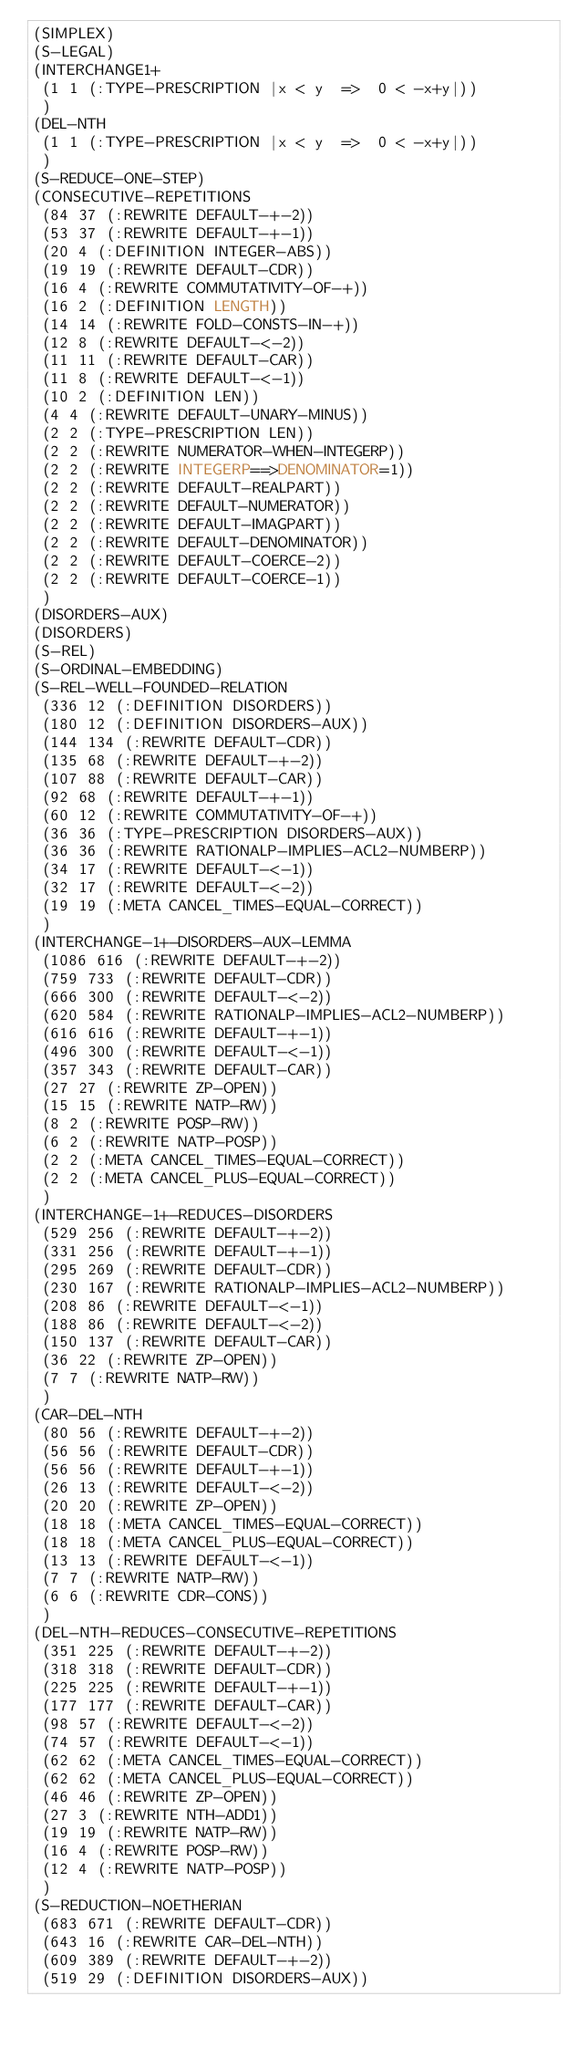<code> <loc_0><loc_0><loc_500><loc_500><_Lisp_>(SIMPLEX)
(S-LEGAL)
(INTERCHANGE1+
 (1 1 (:TYPE-PRESCRIPTION |x < y  =>  0 < -x+y|))
 )
(DEL-NTH
 (1 1 (:TYPE-PRESCRIPTION |x < y  =>  0 < -x+y|))
 )
(S-REDUCE-ONE-STEP)
(CONSECUTIVE-REPETITIONS
 (84 37 (:REWRITE DEFAULT-+-2))
 (53 37 (:REWRITE DEFAULT-+-1))
 (20 4 (:DEFINITION INTEGER-ABS))
 (19 19 (:REWRITE DEFAULT-CDR))
 (16 4 (:REWRITE COMMUTATIVITY-OF-+))
 (16 2 (:DEFINITION LENGTH))
 (14 14 (:REWRITE FOLD-CONSTS-IN-+))
 (12 8 (:REWRITE DEFAULT-<-2))
 (11 11 (:REWRITE DEFAULT-CAR))
 (11 8 (:REWRITE DEFAULT-<-1))
 (10 2 (:DEFINITION LEN))
 (4 4 (:REWRITE DEFAULT-UNARY-MINUS))
 (2 2 (:TYPE-PRESCRIPTION LEN))
 (2 2 (:REWRITE NUMERATOR-WHEN-INTEGERP))
 (2 2 (:REWRITE INTEGERP==>DENOMINATOR=1))
 (2 2 (:REWRITE DEFAULT-REALPART))
 (2 2 (:REWRITE DEFAULT-NUMERATOR))
 (2 2 (:REWRITE DEFAULT-IMAGPART))
 (2 2 (:REWRITE DEFAULT-DENOMINATOR))
 (2 2 (:REWRITE DEFAULT-COERCE-2))
 (2 2 (:REWRITE DEFAULT-COERCE-1))
 )
(DISORDERS-AUX)
(DISORDERS)
(S-REL)
(S-ORDINAL-EMBEDDING)
(S-REL-WELL-FOUNDED-RELATION
 (336 12 (:DEFINITION DISORDERS))
 (180 12 (:DEFINITION DISORDERS-AUX))
 (144 134 (:REWRITE DEFAULT-CDR))
 (135 68 (:REWRITE DEFAULT-+-2))
 (107 88 (:REWRITE DEFAULT-CAR))
 (92 68 (:REWRITE DEFAULT-+-1))
 (60 12 (:REWRITE COMMUTATIVITY-OF-+))
 (36 36 (:TYPE-PRESCRIPTION DISORDERS-AUX))
 (36 36 (:REWRITE RATIONALP-IMPLIES-ACL2-NUMBERP))
 (34 17 (:REWRITE DEFAULT-<-1))
 (32 17 (:REWRITE DEFAULT-<-2))
 (19 19 (:META CANCEL_TIMES-EQUAL-CORRECT))
 )
(INTERCHANGE-1+-DISORDERS-AUX-LEMMA
 (1086 616 (:REWRITE DEFAULT-+-2))
 (759 733 (:REWRITE DEFAULT-CDR))
 (666 300 (:REWRITE DEFAULT-<-2))
 (620 584 (:REWRITE RATIONALP-IMPLIES-ACL2-NUMBERP))
 (616 616 (:REWRITE DEFAULT-+-1))
 (496 300 (:REWRITE DEFAULT-<-1))
 (357 343 (:REWRITE DEFAULT-CAR))
 (27 27 (:REWRITE ZP-OPEN))
 (15 15 (:REWRITE NATP-RW))
 (8 2 (:REWRITE POSP-RW))
 (6 2 (:REWRITE NATP-POSP))
 (2 2 (:META CANCEL_TIMES-EQUAL-CORRECT))
 (2 2 (:META CANCEL_PLUS-EQUAL-CORRECT))
 )
(INTERCHANGE-1+-REDUCES-DISORDERS
 (529 256 (:REWRITE DEFAULT-+-2))
 (331 256 (:REWRITE DEFAULT-+-1))
 (295 269 (:REWRITE DEFAULT-CDR))
 (230 167 (:REWRITE RATIONALP-IMPLIES-ACL2-NUMBERP))
 (208 86 (:REWRITE DEFAULT-<-1))
 (188 86 (:REWRITE DEFAULT-<-2))
 (150 137 (:REWRITE DEFAULT-CAR))
 (36 22 (:REWRITE ZP-OPEN))
 (7 7 (:REWRITE NATP-RW))
 )
(CAR-DEL-NTH
 (80 56 (:REWRITE DEFAULT-+-2))
 (56 56 (:REWRITE DEFAULT-CDR))
 (56 56 (:REWRITE DEFAULT-+-1))
 (26 13 (:REWRITE DEFAULT-<-2))
 (20 20 (:REWRITE ZP-OPEN))
 (18 18 (:META CANCEL_TIMES-EQUAL-CORRECT))
 (18 18 (:META CANCEL_PLUS-EQUAL-CORRECT))
 (13 13 (:REWRITE DEFAULT-<-1))
 (7 7 (:REWRITE NATP-RW))
 (6 6 (:REWRITE CDR-CONS))
 )
(DEL-NTH-REDUCES-CONSECUTIVE-REPETITIONS
 (351 225 (:REWRITE DEFAULT-+-2))
 (318 318 (:REWRITE DEFAULT-CDR))
 (225 225 (:REWRITE DEFAULT-+-1))
 (177 177 (:REWRITE DEFAULT-CAR))
 (98 57 (:REWRITE DEFAULT-<-2))
 (74 57 (:REWRITE DEFAULT-<-1))
 (62 62 (:META CANCEL_TIMES-EQUAL-CORRECT))
 (62 62 (:META CANCEL_PLUS-EQUAL-CORRECT))
 (46 46 (:REWRITE ZP-OPEN))
 (27 3 (:REWRITE NTH-ADD1))
 (19 19 (:REWRITE NATP-RW))
 (16 4 (:REWRITE POSP-RW))
 (12 4 (:REWRITE NATP-POSP))
 )
(S-REDUCTION-NOETHERIAN
 (683 671 (:REWRITE DEFAULT-CDR))
 (643 16 (:REWRITE CAR-DEL-NTH))
 (609 389 (:REWRITE DEFAULT-+-2))
 (519 29 (:DEFINITION DISORDERS-AUX))</code> 